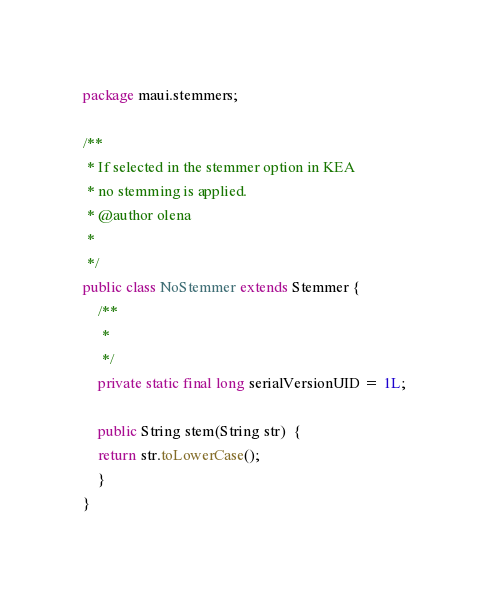Convert code to text. <code><loc_0><loc_0><loc_500><loc_500><_Java_>package maui.stemmers;

/**
 * If selected in the stemmer option in KEA
 * no stemming is applied.
 * @author olena
 *
 */
public class NoStemmer extends Stemmer {
    /**
	 * 
	 */
	private static final long serialVersionUID = 1L;

	public String stem(String str)  {
	return str.toLowerCase();
    }
}</code> 